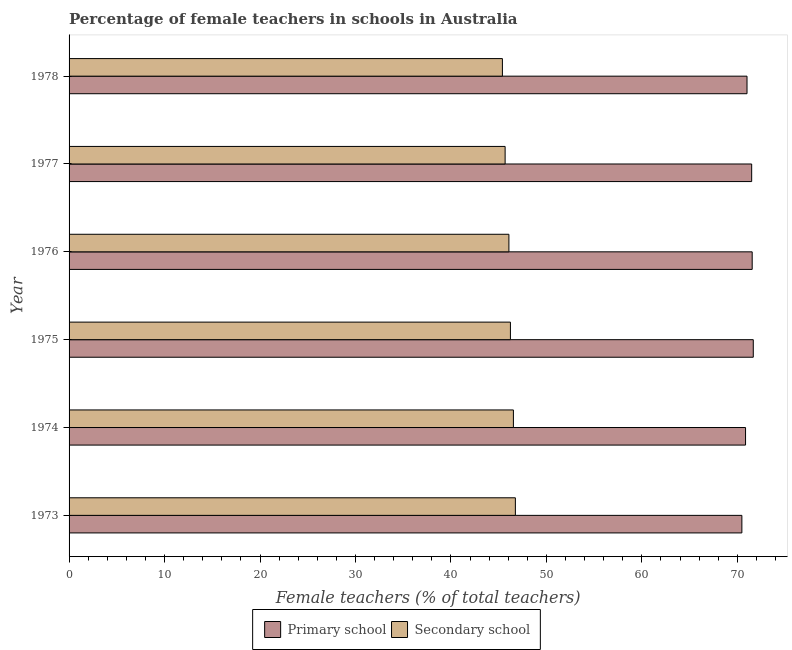How many different coloured bars are there?
Your response must be concise. 2. How many groups of bars are there?
Keep it short and to the point. 6. Are the number of bars per tick equal to the number of legend labels?
Your answer should be very brief. Yes. Are the number of bars on each tick of the Y-axis equal?
Your response must be concise. Yes. How many bars are there on the 6th tick from the top?
Your answer should be compact. 2. What is the label of the 5th group of bars from the top?
Your response must be concise. 1974. What is the percentage of female teachers in secondary schools in 1977?
Offer a very short reply. 45.68. Across all years, what is the maximum percentage of female teachers in secondary schools?
Keep it short and to the point. 46.75. Across all years, what is the minimum percentage of female teachers in primary schools?
Ensure brevity in your answer.  70.48. In which year was the percentage of female teachers in primary schools maximum?
Your answer should be compact. 1975. In which year was the percentage of female teachers in secondary schools minimum?
Provide a short and direct response. 1978. What is the total percentage of female teachers in secondary schools in the graph?
Give a very brief answer. 276.68. What is the difference between the percentage of female teachers in primary schools in 1973 and that in 1978?
Provide a succinct answer. -0.54. What is the difference between the percentage of female teachers in primary schools in 1974 and the percentage of female teachers in secondary schools in 1977?
Your answer should be compact. 25.19. What is the average percentage of female teachers in secondary schools per year?
Your answer should be very brief. 46.11. In the year 1976, what is the difference between the percentage of female teachers in primary schools and percentage of female teachers in secondary schools?
Your answer should be compact. 25.48. In how many years, is the percentage of female teachers in primary schools greater than 34 %?
Offer a terse response. 6. What is the ratio of the percentage of female teachers in primary schools in 1973 to that in 1976?
Your answer should be compact. 0.98. Is the percentage of female teachers in secondary schools in 1975 less than that in 1978?
Offer a very short reply. No. Is the difference between the percentage of female teachers in primary schools in 1973 and 1974 greater than the difference between the percentage of female teachers in secondary schools in 1973 and 1974?
Provide a succinct answer. No. What is the difference between the highest and the second highest percentage of female teachers in primary schools?
Offer a very short reply. 0.11. What is the difference between the highest and the lowest percentage of female teachers in secondary schools?
Provide a short and direct response. 1.36. In how many years, is the percentage of female teachers in primary schools greater than the average percentage of female teachers in primary schools taken over all years?
Ensure brevity in your answer.  3. What does the 1st bar from the top in 1978 represents?
Your response must be concise. Secondary school. What does the 2nd bar from the bottom in 1973 represents?
Give a very brief answer. Secondary school. How many bars are there?
Your answer should be compact. 12. Are the values on the major ticks of X-axis written in scientific E-notation?
Keep it short and to the point. No. Does the graph contain any zero values?
Give a very brief answer. No. Does the graph contain grids?
Your answer should be compact. No. What is the title of the graph?
Give a very brief answer. Percentage of female teachers in schools in Australia. What is the label or title of the X-axis?
Keep it short and to the point. Female teachers (% of total teachers). What is the Female teachers (% of total teachers) in Primary school in 1973?
Offer a terse response. 70.48. What is the Female teachers (% of total teachers) in Secondary school in 1973?
Ensure brevity in your answer.  46.75. What is the Female teachers (% of total teachers) of Primary school in 1974?
Your answer should be compact. 70.86. What is the Female teachers (% of total teachers) in Secondary school in 1974?
Your answer should be very brief. 46.55. What is the Female teachers (% of total teachers) in Primary school in 1975?
Make the answer very short. 71.67. What is the Female teachers (% of total teachers) of Secondary school in 1975?
Provide a succinct answer. 46.23. What is the Female teachers (% of total teachers) of Primary school in 1976?
Offer a terse response. 71.56. What is the Female teachers (% of total teachers) of Secondary school in 1976?
Give a very brief answer. 46.07. What is the Female teachers (% of total teachers) of Primary school in 1977?
Offer a very short reply. 71.5. What is the Female teachers (% of total teachers) of Secondary school in 1977?
Give a very brief answer. 45.68. What is the Female teachers (% of total teachers) of Primary school in 1978?
Provide a short and direct response. 71.02. What is the Female teachers (% of total teachers) of Secondary school in 1978?
Offer a very short reply. 45.39. Across all years, what is the maximum Female teachers (% of total teachers) in Primary school?
Ensure brevity in your answer.  71.67. Across all years, what is the maximum Female teachers (% of total teachers) in Secondary school?
Provide a succinct answer. 46.75. Across all years, what is the minimum Female teachers (% of total teachers) in Primary school?
Your response must be concise. 70.48. Across all years, what is the minimum Female teachers (% of total teachers) in Secondary school?
Your response must be concise. 45.39. What is the total Female teachers (% of total teachers) of Primary school in the graph?
Make the answer very short. 427.1. What is the total Female teachers (% of total teachers) in Secondary school in the graph?
Your answer should be compact. 276.68. What is the difference between the Female teachers (% of total teachers) of Primary school in 1973 and that in 1974?
Your response must be concise. -0.38. What is the difference between the Female teachers (% of total teachers) in Secondary school in 1973 and that in 1974?
Offer a terse response. 0.21. What is the difference between the Female teachers (% of total teachers) in Primary school in 1973 and that in 1975?
Keep it short and to the point. -1.2. What is the difference between the Female teachers (% of total teachers) of Secondary school in 1973 and that in 1975?
Ensure brevity in your answer.  0.52. What is the difference between the Female teachers (% of total teachers) of Primary school in 1973 and that in 1976?
Your response must be concise. -1.08. What is the difference between the Female teachers (% of total teachers) of Secondary school in 1973 and that in 1976?
Provide a succinct answer. 0.68. What is the difference between the Female teachers (% of total teachers) of Primary school in 1973 and that in 1977?
Your answer should be very brief. -1.03. What is the difference between the Female teachers (% of total teachers) of Secondary school in 1973 and that in 1977?
Your answer should be very brief. 1.07. What is the difference between the Female teachers (% of total teachers) of Primary school in 1973 and that in 1978?
Offer a terse response. -0.54. What is the difference between the Female teachers (% of total teachers) of Secondary school in 1973 and that in 1978?
Your answer should be compact. 1.36. What is the difference between the Female teachers (% of total teachers) of Primary school in 1974 and that in 1975?
Your answer should be very brief. -0.81. What is the difference between the Female teachers (% of total teachers) of Secondary school in 1974 and that in 1975?
Provide a short and direct response. 0.31. What is the difference between the Female teachers (% of total teachers) of Primary school in 1974 and that in 1976?
Offer a very short reply. -0.7. What is the difference between the Female teachers (% of total teachers) in Secondary school in 1974 and that in 1976?
Provide a succinct answer. 0.47. What is the difference between the Female teachers (% of total teachers) in Primary school in 1974 and that in 1977?
Your answer should be very brief. -0.64. What is the difference between the Female teachers (% of total teachers) of Secondary school in 1974 and that in 1977?
Your answer should be very brief. 0.87. What is the difference between the Female teachers (% of total teachers) in Primary school in 1974 and that in 1978?
Offer a very short reply. -0.15. What is the difference between the Female teachers (% of total teachers) in Secondary school in 1974 and that in 1978?
Provide a succinct answer. 1.15. What is the difference between the Female teachers (% of total teachers) of Primary school in 1975 and that in 1976?
Your response must be concise. 0.11. What is the difference between the Female teachers (% of total teachers) in Secondary school in 1975 and that in 1976?
Offer a terse response. 0.16. What is the difference between the Female teachers (% of total teachers) in Primary school in 1975 and that in 1977?
Make the answer very short. 0.17. What is the difference between the Female teachers (% of total teachers) of Secondary school in 1975 and that in 1977?
Keep it short and to the point. 0.56. What is the difference between the Female teachers (% of total teachers) of Primary school in 1975 and that in 1978?
Make the answer very short. 0.66. What is the difference between the Female teachers (% of total teachers) in Secondary school in 1975 and that in 1978?
Provide a succinct answer. 0.84. What is the difference between the Female teachers (% of total teachers) in Primary school in 1976 and that in 1977?
Make the answer very short. 0.06. What is the difference between the Female teachers (% of total teachers) in Secondary school in 1976 and that in 1977?
Provide a succinct answer. 0.4. What is the difference between the Female teachers (% of total teachers) of Primary school in 1976 and that in 1978?
Give a very brief answer. 0.54. What is the difference between the Female teachers (% of total teachers) of Secondary school in 1976 and that in 1978?
Ensure brevity in your answer.  0.68. What is the difference between the Female teachers (% of total teachers) in Primary school in 1977 and that in 1978?
Offer a terse response. 0.49. What is the difference between the Female teachers (% of total teachers) in Secondary school in 1977 and that in 1978?
Ensure brevity in your answer.  0.28. What is the difference between the Female teachers (% of total teachers) in Primary school in 1973 and the Female teachers (% of total teachers) in Secondary school in 1974?
Your response must be concise. 23.93. What is the difference between the Female teachers (% of total teachers) in Primary school in 1973 and the Female teachers (% of total teachers) in Secondary school in 1975?
Ensure brevity in your answer.  24.24. What is the difference between the Female teachers (% of total teachers) of Primary school in 1973 and the Female teachers (% of total teachers) of Secondary school in 1976?
Offer a very short reply. 24.4. What is the difference between the Female teachers (% of total teachers) of Primary school in 1973 and the Female teachers (% of total teachers) of Secondary school in 1977?
Make the answer very short. 24.8. What is the difference between the Female teachers (% of total teachers) in Primary school in 1973 and the Female teachers (% of total teachers) in Secondary school in 1978?
Your response must be concise. 25.09. What is the difference between the Female teachers (% of total teachers) in Primary school in 1974 and the Female teachers (% of total teachers) in Secondary school in 1975?
Provide a succinct answer. 24.63. What is the difference between the Female teachers (% of total teachers) in Primary school in 1974 and the Female teachers (% of total teachers) in Secondary school in 1976?
Ensure brevity in your answer.  24.79. What is the difference between the Female teachers (% of total teachers) in Primary school in 1974 and the Female teachers (% of total teachers) in Secondary school in 1977?
Keep it short and to the point. 25.19. What is the difference between the Female teachers (% of total teachers) of Primary school in 1974 and the Female teachers (% of total teachers) of Secondary school in 1978?
Offer a very short reply. 25.47. What is the difference between the Female teachers (% of total teachers) of Primary school in 1975 and the Female teachers (% of total teachers) of Secondary school in 1976?
Keep it short and to the point. 25.6. What is the difference between the Female teachers (% of total teachers) of Primary school in 1975 and the Female teachers (% of total teachers) of Secondary school in 1977?
Offer a very short reply. 26. What is the difference between the Female teachers (% of total teachers) of Primary school in 1975 and the Female teachers (% of total teachers) of Secondary school in 1978?
Give a very brief answer. 26.28. What is the difference between the Female teachers (% of total teachers) in Primary school in 1976 and the Female teachers (% of total teachers) in Secondary school in 1977?
Your answer should be compact. 25.88. What is the difference between the Female teachers (% of total teachers) in Primary school in 1976 and the Female teachers (% of total teachers) in Secondary school in 1978?
Your response must be concise. 26.17. What is the difference between the Female teachers (% of total teachers) in Primary school in 1977 and the Female teachers (% of total teachers) in Secondary school in 1978?
Provide a short and direct response. 26.11. What is the average Female teachers (% of total teachers) in Primary school per year?
Provide a succinct answer. 71.18. What is the average Female teachers (% of total teachers) in Secondary school per year?
Make the answer very short. 46.11. In the year 1973, what is the difference between the Female teachers (% of total teachers) in Primary school and Female teachers (% of total teachers) in Secondary school?
Provide a short and direct response. 23.73. In the year 1974, what is the difference between the Female teachers (% of total teachers) of Primary school and Female teachers (% of total teachers) of Secondary school?
Ensure brevity in your answer.  24.32. In the year 1975, what is the difference between the Female teachers (% of total teachers) of Primary school and Female teachers (% of total teachers) of Secondary school?
Offer a very short reply. 25.44. In the year 1976, what is the difference between the Female teachers (% of total teachers) in Primary school and Female teachers (% of total teachers) in Secondary school?
Ensure brevity in your answer.  25.49. In the year 1977, what is the difference between the Female teachers (% of total teachers) of Primary school and Female teachers (% of total teachers) of Secondary school?
Offer a very short reply. 25.83. In the year 1978, what is the difference between the Female teachers (% of total teachers) of Primary school and Female teachers (% of total teachers) of Secondary school?
Provide a short and direct response. 25.63. What is the ratio of the Female teachers (% of total teachers) of Primary school in 1973 to that in 1974?
Give a very brief answer. 0.99. What is the ratio of the Female teachers (% of total teachers) in Secondary school in 1973 to that in 1974?
Provide a short and direct response. 1. What is the ratio of the Female teachers (% of total teachers) in Primary school in 1973 to that in 1975?
Keep it short and to the point. 0.98. What is the ratio of the Female teachers (% of total teachers) of Secondary school in 1973 to that in 1975?
Make the answer very short. 1.01. What is the ratio of the Female teachers (% of total teachers) in Primary school in 1973 to that in 1976?
Keep it short and to the point. 0.98. What is the ratio of the Female teachers (% of total teachers) in Secondary school in 1973 to that in 1976?
Ensure brevity in your answer.  1.01. What is the ratio of the Female teachers (% of total teachers) of Primary school in 1973 to that in 1977?
Keep it short and to the point. 0.99. What is the ratio of the Female teachers (% of total teachers) of Secondary school in 1973 to that in 1977?
Your answer should be compact. 1.02. What is the ratio of the Female teachers (% of total teachers) of Primary school in 1973 to that in 1978?
Provide a short and direct response. 0.99. What is the ratio of the Female teachers (% of total teachers) of Secondary school in 1973 to that in 1978?
Keep it short and to the point. 1.03. What is the ratio of the Female teachers (% of total teachers) in Primary school in 1974 to that in 1975?
Your response must be concise. 0.99. What is the ratio of the Female teachers (% of total teachers) in Secondary school in 1974 to that in 1975?
Provide a succinct answer. 1.01. What is the ratio of the Female teachers (% of total teachers) in Primary school in 1974 to that in 1976?
Offer a very short reply. 0.99. What is the ratio of the Female teachers (% of total teachers) in Secondary school in 1974 to that in 1976?
Your answer should be very brief. 1.01. What is the ratio of the Female teachers (% of total teachers) in Secondary school in 1974 to that in 1977?
Your answer should be compact. 1.02. What is the ratio of the Female teachers (% of total teachers) of Primary school in 1974 to that in 1978?
Offer a very short reply. 1. What is the ratio of the Female teachers (% of total teachers) of Secondary school in 1974 to that in 1978?
Provide a short and direct response. 1.03. What is the ratio of the Female teachers (% of total teachers) in Primary school in 1975 to that in 1976?
Offer a very short reply. 1. What is the ratio of the Female teachers (% of total teachers) in Secondary school in 1975 to that in 1976?
Your answer should be very brief. 1. What is the ratio of the Female teachers (% of total teachers) in Secondary school in 1975 to that in 1977?
Provide a short and direct response. 1.01. What is the ratio of the Female teachers (% of total teachers) of Primary school in 1975 to that in 1978?
Your answer should be very brief. 1.01. What is the ratio of the Female teachers (% of total teachers) of Secondary school in 1975 to that in 1978?
Provide a short and direct response. 1.02. What is the ratio of the Female teachers (% of total teachers) in Secondary school in 1976 to that in 1977?
Your answer should be compact. 1.01. What is the ratio of the Female teachers (% of total teachers) of Primary school in 1976 to that in 1978?
Make the answer very short. 1.01. What is the ratio of the Female teachers (% of total teachers) in Secondary school in 1977 to that in 1978?
Your response must be concise. 1.01. What is the difference between the highest and the second highest Female teachers (% of total teachers) in Primary school?
Your answer should be very brief. 0.11. What is the difference between the highest and the second highest Female teachers (% of total teachers) in Secondary school?
Your answer should be compact. 0.21. What is the difference between the highest and the lowest Female teachers (% of total teachers) of Primary school?
Provide a short and direct response. 1.2. What is the difference between the highest and the lowest Female teachers (% of total teachers) in Secondary school?
Give a very brief answer. 1.36. 